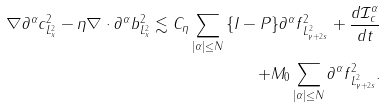Convert formula to latex. <formula><loc_0><loc_0><loc_500><loc_500>\| \nabla \partial ^ { \alpha } c \| ^ { 2 } _ { L ^ { 2 } _ { x } } - \eta \| \nabla \cdot \partial ^ { \alpha } b \| ^ { 2 } _ { L ^ { 2 } _ { x } } \lesssim C _ { \eta } \sum _ { | \alpha | \leq N } \| \{ { I - P } \} \partial ^ { \alpha } f \| ^ { 2 } _ { L ^ { 2 } _ { \gamma + 2 s } } + \frac { d \mathcal { I } _ { c } ^ { \alpha } } { d t } \\ + M _ { 0 } \sum _ { | \alpha | \leq N } \| \partial ^ { \alpha } f \| _ { L ^ { 2 } _ { \gamma + 2 s } } ^ { 2 } .</formula> 